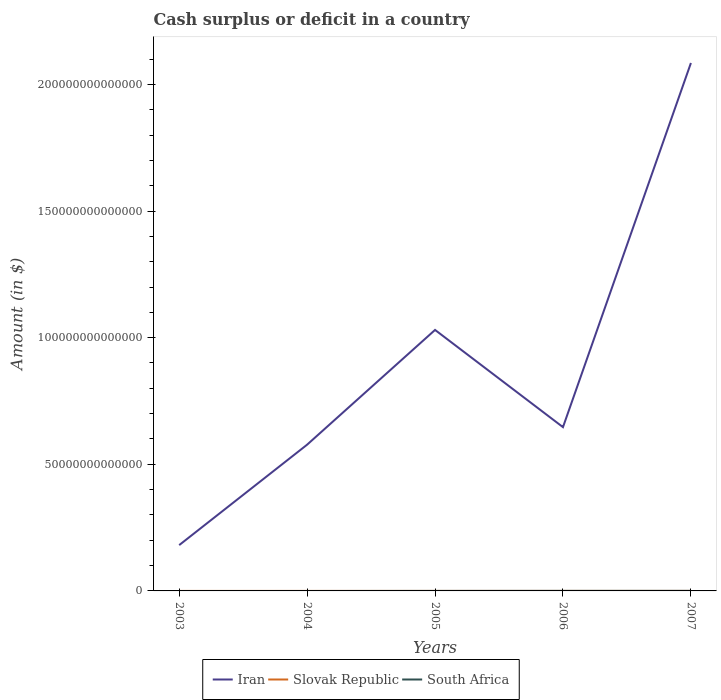How many different coloured lines are there?
Offer a very short reply. 2. Across all years, what is the maximum amount of cash surplus or deficit in Slovak Republic?
Provide a short and direct response. 0. What is the total amount of cash surplus or deficit in Iran in the graph?
Offer a very short reply. -1.05e+14. What is the difference between the highest and the second highest amount of cash surplus or deficit in Iran?
Keep it short and to the point. 1.90e+14. How many lines are there?
Provide a short and direct response. 2. What is the difference between two consecutive major ticks on the Y-axis?
Give a very brief answer. 5.00e+13. Does the graph contain grids?
Keep it short and to the point. No. How many legend labels are there?
Your response must be concise. 3. How are the legend labels stacked?
Provide a succinct answer. Horizontal. What is the title of the graph?
Ensure brevity in your answer.  Cash surplus or deficit in a country. What is the label or title of the X-axis?
Your response must be concise. Years. What is the label or title of the Y-axis?
Keep it short and to the point. Amount (in $). What is the Amount (in $) of Iran in 2003?
Make the answer very short. 1.81e+13. What is the Amount (in $) in Slovak Republic in 2003?
Your answer should be compact. 0. What is the Amount (in $) in South Africa in 2003?
Your answer should be very brief. 0. What is the Amount (in $) of Iran in 2004?
Your answer should be compact. 5.77e+13. What is the Amount (in $) in Iran in 2005?
Give a very brief answer. 1.03e+14. What is the Amount (in $) of Iran in 2006?
Offer a very short reply. 6.47e+13. What is the Amount (in $) in Slovak Republic in 2006?
Give a very brief answer. 0. What is the Amount (in $) of South Africa in 2006?
Your response must be concise. 1.61e+1. What is the Amount (in $) in Iran in 2007?
Your answer should be compact. 2.08e+14. What is the Amount (in $) in South Africa in 2007?
Your answer should be compact. 2.17e+1. Across all years, what is the maximum Amount (in $) in Iran?
Your answer should be compact. 2.08e+14. Across all years, what is the maximum Amount (in $) in South Africa?
Your answer should be very brief. 2.17e+1. Across all years, what is the minimum Amount (in $) in Iran?
Keep it short and to the point. 1.81e+13. What is the total Amount (in $) in Iran in the graph?
Provide a succinct answer. 4.52e+14. What is the total Amount (in $) of Slovak Republic in the graph?
Provide a short and direct response. 0. What is the total Amount (in $) in South Africa in the graph?
Offer a very short reply. 3.78e+1. What is the difference between the Amount (in $) of Iran in 2003 and that in 2004?
Keep it short and to the point. -3.97e+13. What is the difference between the Amount (in $) of Iran in 2003 and that in 2005?
Provide a succinct answer. -8.50e+13. What is the difference between the Amount (in $) of Iran in 2003 and that in 2006?
Your answer should be compact. -4.66e+13. What is the difference between the Amount (in $) in Iran in 2003 and that in 2007?
Your response must be concise. -1.90e+14. What is the difference between the Amount (in $) in Iran in 2004 and that in 2005?
Give a very brief answer. -4.53e+13. What is the difference between the Amount (in $) in Iran in 2004 and that in 2006?
Give a very brief answer. -6.92e+12. What is the difference between the Amount (in $) of Iran in 2004 and that in 2007?
Give a very brief answer. -1.51e+14. What is the difference between the Amount (in $) of Iran in 2005 and that in 2006?
Offer a very short reply. 3.84e+13. What is the difference between the Amount (in $) of Iran in 2005 and that in 2007?
Offer a very short reply. -1.05e+14. What is the difference between the Amount (in $) in Iran in 2006 and that in 2007?
Make the answer very short. -1.44e+14. What is the difference between the Amount (in $) in South Africa in 2006 and that in 2007?
Provide a succinct answer. -5.61e+09. What is the difference between the Amount (in $) of Iran in 2003 and the Amount (in $) of South Africa in 2006?
Ensure brevity in your answer.  1.81e+13. What is the difference between the Amount (in $) of Iran in 2003 and the Amount (in $) of South Africa in 2007?
Provide a succinct answer. 1.81e+13. What is the difference between the Amount (in $) in Iran in 2004 and the Amount (in $) in South Africa in 2006?
Make the answer very short. 5.77e+13. What is the difference between the Amount (in $) of Iran in 2004 and the Amount (in $) of South Africa in 2007?
Your answer should be very brief. 5.77e+13. What is the difference between the Amount (in $) of Iran in 2005 and the Amount (in $) of South Africa in 2006?
Keep it short and to the point. 1.03e+14. What is the difference between the Amount (in $) of Iran in 2005 and the Amount (in $) of South Africa in 2007?
Ensure brevity in your answer.  1.03e+14. What is the difference between the Amount (in $) of Iran in 2006 and the Amount (in $) of South Africa in 2007?
Your answer should be very brief. 6.46e+13. What is the average Amount (in $) in Iran per year?
Ensure brevity in your answer.  9.04e+13. What is the average Amount (in $) in Slovak Republic per year?
Provide a short and direct response. 0. What is the average Amount (in $) in South Africa per year?
Make the answer very short. 7.56e+09. In the year 2006, what is the difference between the Amount (in $) of Iran and Amount (in $) of South Africa?
Your response must be concise. 6.47e+13. In the year 2007, what is the difference between the Amount (in $) in Iran and Amount (in $) in South Africa?
Keep it short and to the point. 2.08e+14. What is the ratio of the Amount (in $) in Iran in 2003 to that in 2004?
Offer a very short reply. 0.31. What is the ratio of the Amount (in $) of Iran in 2003 to that in 2005?
Provide a short and direct response. 0.18. What is the ratio of the Amount (in $) of Iran in 2003 to that in 2006?
Your answer should be very brief. 0.28. What is the ratio of the Amount (in $) in Iran in 2003 to that in 2007?
Provide a succinct answer. 0.09. What is the ratio of the Amount (in $) in Iran in 2004 to that in 2005?
Make the answer very short. 0.56. What is the ratio of the Amount (in $) in Iran in 2004 to that in 2006?
Offer a terse response. 0.89. What is the ratio of the Amount (in $) of Iran in 2004 to that in 2007?
Your answer should be compact. 0.28. What is the ratio of the Amount (in $) of Iran in 2005 to that in 2006?
Provide a succinct answer. 1.59. What is the ratio of the Amount (in $) in Iran in 2005 to that in 2007?
Offer a terse response. 0.49. What is the ratio of the Amount (in $) in Iran in 2006 to that in 2007?
Give a very brief answer. 0.31. What is the ratio of the Amount (in $) in South Africa in 2006 to that in 2007?
Your answer should be very brief. 0.74. What is the difference between the highest and the second highest Amount (in $) in Iran?
Your answer should be compact. 1.05e+14. What is the difference between the highest and the lowest Amount (in $) in Iran?
Your answer should be very brief. 1.90e+14. What is the difference between the highest and the lowest Amount (in $) in South Africa?
Provide a short and direct response. 2.17e+1. 